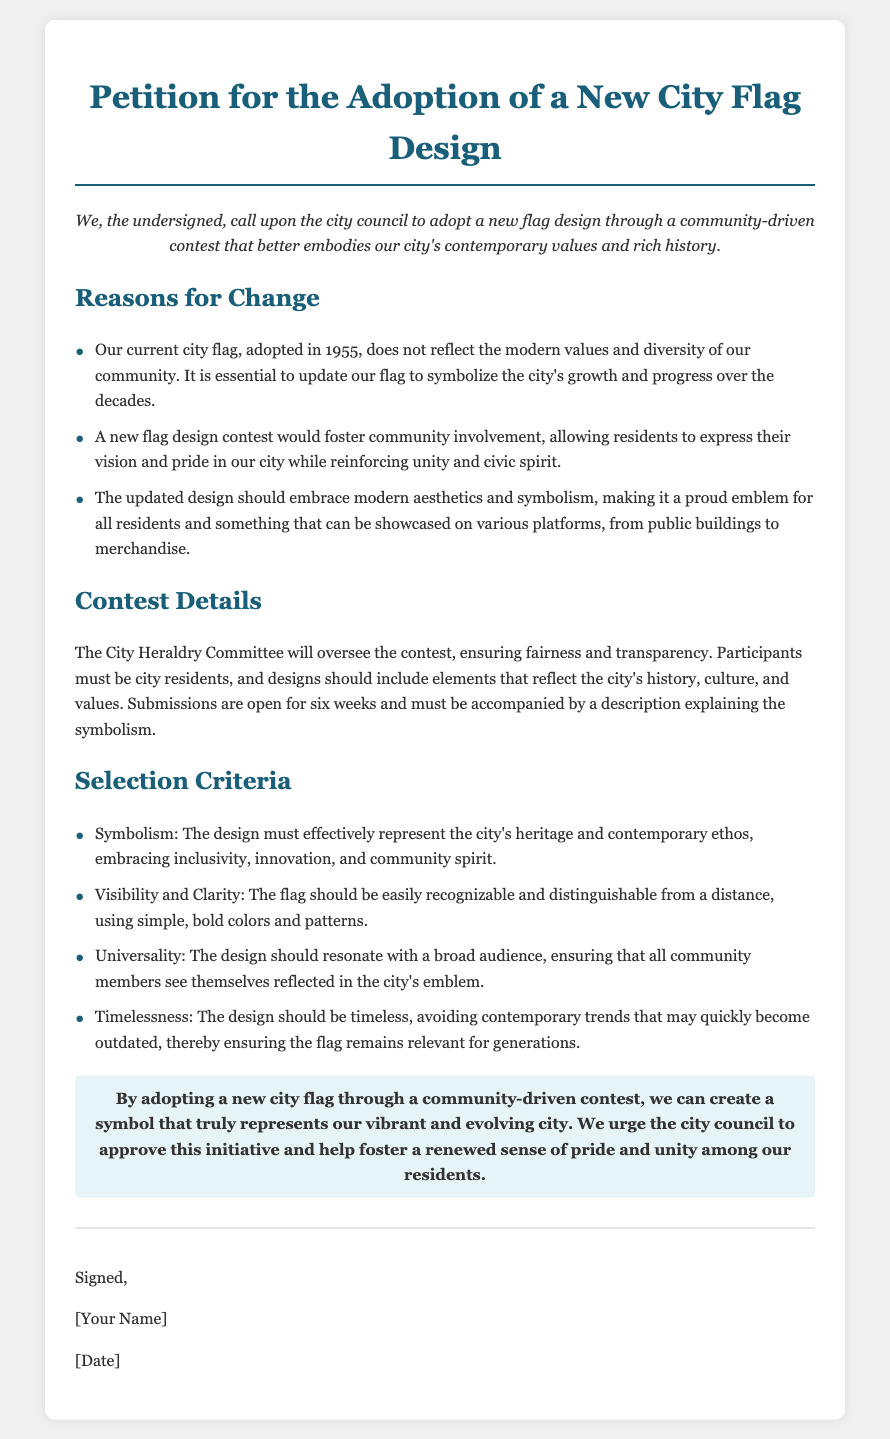What year was the current city flag adopted? The document states that the current city flag was adopted in 1955.
Answer: 1955 How long is the submission period for the design contest? The document mentions that submissions are open for six weeks.
Answer: six weeks Who will oversee the contest? The document indicates that the City Heraldry Committee will oversee the contest.
Answer: City Heraldry Committee What elements should the design include? According to the document, designs should reflect the city's history, culture, and values.
Answer: history, culture, values What is one of the selection criteria for the flag design? The document lists "Symbolism" as a criterion that must represent the city's heritage and contemporary ethos.
Answer: Symbolism How does the petition propose to foster community spirit? The petition suggests that a new flag design contest would allow residents to express their vision and pride, reinforcing unity and civic spirit.
Answer: community involvement What color scheme is suggested for the flag? The document implies that the flag should use simple, bold colors for better visibility.
Answer: bold colors What is the conclusion of the petition? The conclusion urges the city council to approve the initiative to create a new symbol representing the city.
Answer: adopt a new city flag 